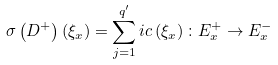Convert formula to latex. <formula><loc_0><loc_0><loc_500><loc_500>\sigma \left ( D ^ { + } \right ) \left ( \xi _ { x } \right ) = \sum _ { j = 1 } ^ { q ^ { \prime } } i c \left ( \xi _ { x } \right ) \colon E _ { x } ^ { + } \rightarrow E _ { x } ^ { - }</formula> 